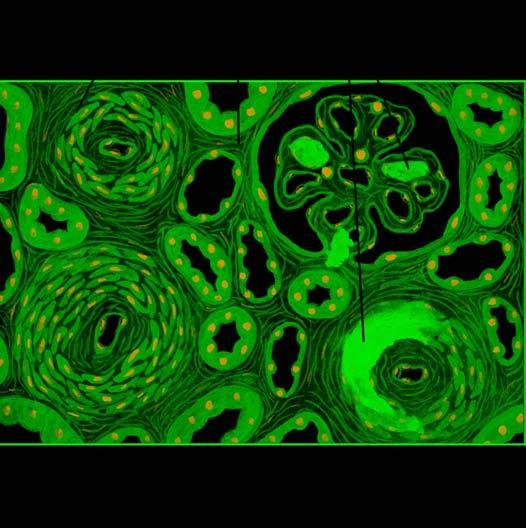re numbers necrotising arteriolitis and hyperplastic intimal sclerosis or onion-skin proliferation?
Answer the question using a single word or phrase. No 